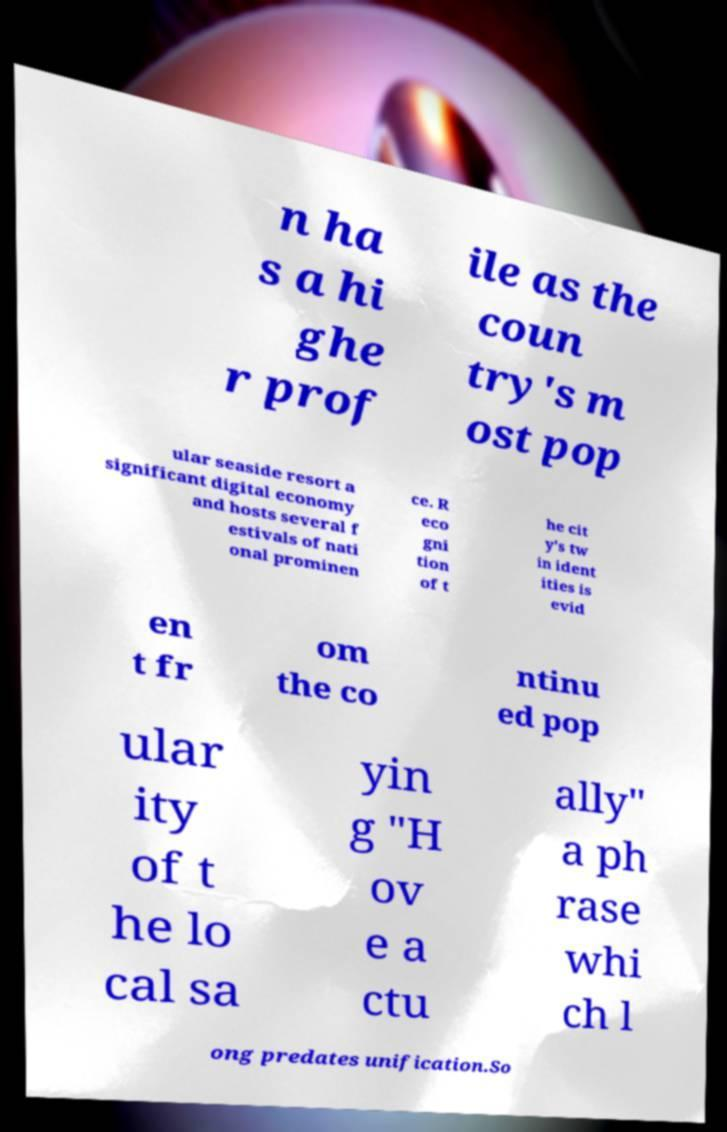Could you assist in decoding the text presented in this image and type it out clearly? n ha s a hi ghe r prof ile as the coun try's m ost pop ular seaside resort a significant digital economy and hosts several f estivals of nati onal prominen ce. R eco gni tion of t he cit y's tw in ident ities is evid en t fr om the co ntinu ed pop ular ity of t he lo cal sa yin g "H ov e a ctu ally" a ph rase whi ch l ong predates unification.So 